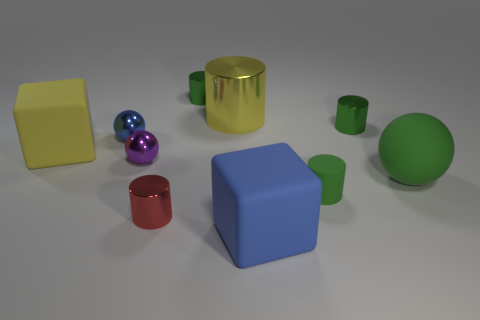Is the shape of the small red thing the same as the big yellow rubber thing?
Make the answer very short. No. What number of spheres are either small red things or blue metallic things?
Make the answer very short. 1. What color is the large object that is made of the same material as the small red cylinder?
Make the answer very short. Yellow. There is a purple metal object that is left of the blue matte object; does it have the same size as the tiny blue shiny ball?
Offer a terse response. Yes. Are the blue ball and the large cube that is in front of the green matte sphere made of the same material?
Make the answer very short. No. The object on the left side of the blue metallic sphere is what color?
Offer a very short reply. Yellow. Is there a blue thing that is behind the tiny green thing that is in front of the large matte ball?
Make the answer very short. Yes. There is a metal cylinder to the right of the big blue object; is its color the same as the ball on the right side of the small red metal object?
Your answer should be very brief. Yes. How many green metal objects are right of the blue cube?
Provide a succinct answer. 1. How many things have the same color as the rubber cylinder?
Provide a succinct answer. 3. 